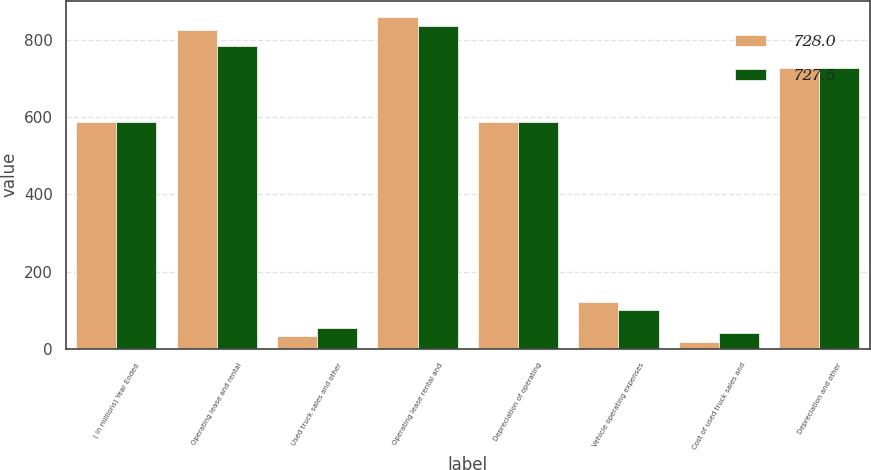Convert chart to OTSL. <chart><loc_0><loc_0><loc_500><loc_500><stacked_bar_chart><ecel><fcel>( in millions) Year Ended<fcel>Operating lease and rental<fcel>Used truck sales and other<fcel>Operating lease rental and<fcel>Depreciation of operating<fcel>Vehicle operating expenses<fcel>Cost of used truck sales and<fcel>Depreciation and other<nl><fcel>728<fcel>587.8<fcel>826<fcel>33.4<fcel>859.4<fcel>588.2<fcel>121.5<fcel>18.3<fcel>728<nl><fcel>727.5<fcel>587.8<fcel>784.6<fcel>53.2<fcel>837.8<fcel>587.4<fcel>99.6<fcel>40.5<fcel>727.5<nl></chart> 